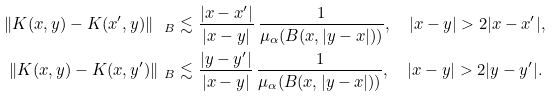Convert formula to latex. <formula><loc_0><loc_0><loc_500><loc_500>\| K ( x , y ) - K ( x ^ { \prime } , y ) \| _ { \ B } & \lesssim \frac { | x - x ^ { \prime } | } { | x - y | } \, \frac { 1 } { \mu _ { \alpha } ( B ( x , | y - x | ) ) } , \quad | x - y | > 2 | x - x ^ { \prime } | , \\ \| K ( x , y ) - K ( x , y ^ { \prime } ) \| _ { \ B } & \lesssim \frac { | y - y ^ { \prime } | } { | x - y | } \, \frac { 1 } { \mu _ { \alpha } ( B ( x , | y - x | ) ) } , \quad | x - y | > 2 | y - y ^ { \prime } | . \\</formula> 